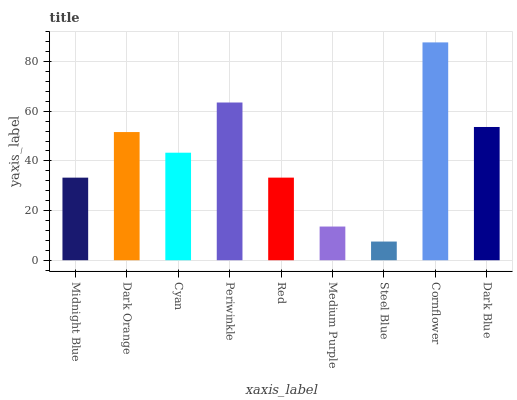Is Dark Orange the minimum?
Answer yes or no. No. Is Dark Orange the maximum?
Answer yes or no. No. Is Dark Orange greater than Midnight Blue?
Answer yes or no. Yes. Is Midnight Blue less than Dark Orange?
Answer yes or no. Yes. Is Midnight Blue greater than Dark Orange?
Answer yes or no. No. Is Dark Orange less than Midnight Blue?
Answer yes or no. No. Is Cyan the high median?
Answer yes or no. Yes. Is Cyan the low median?
Answer yes or no. Yes. Is Dark Orange the high median?
Answer yes or no. No. Is Dark Blue the low median?
Answer yes or no. No. 